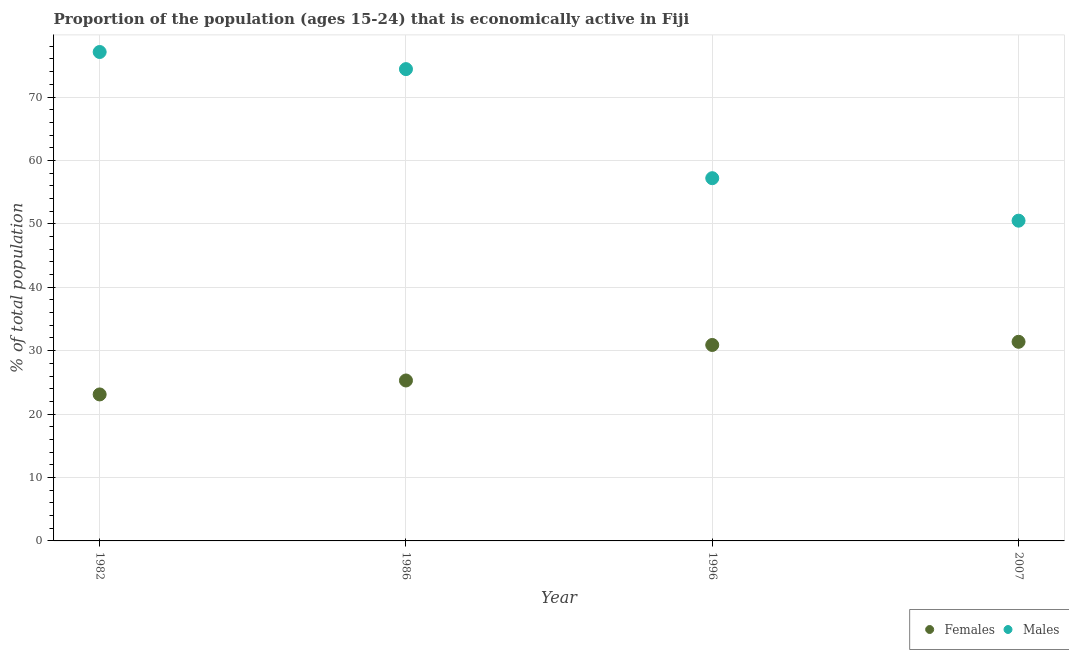Is the number of dotlines equal to the number of legend labels?
Offer a very short reply. Yes. What is the percentage of economically active male population in 1996?
Your answer should be very brief. 57.2. Across all years, what is the maximum percentage of economically active female population?
Give a very brief answer. 31.4. Across all years, what is the minimum percentage of economically active female population?
Your answer should be very brief. 23.1. In which year was the percentage of economically active male population minimum?
Your answer should be very brief. 2007. What is the total percentage of economically active male population in the graph?
Your response must be concise. 259.2. What is the difference between the percentage of economically active female population in 1986 and that in 2007?
Your answer should be compact. -6.1. What is the difference between the percentage of economically active female population in 1986 and the percentage of economically active male population in 1996?
Your answer should be compact. -31.9. What is the average percentage of economically active female population per year?
Offer a very short reply. 27.67. In the year 2007, what is the difference between the percentage of economically active male population and percentage of economically active female population?
Offer a terse response. 19.1. What is the ratio of the percentage of economically active male population in 1982 to that in 1996?
Offer a very short reply. 1.35. What is the difference between the highest and the lowest percentage of economically active female population?
Your response must be concise. 8.3. Is the sum of the percentage of economically active male population in 1982 and 1986 greater than the maximum percentage of economically active female population across all years?
Offer a terse response. Yes. Is the percentage of economically active male population strictly greater than the percentage of economically active female population over the years?
Provide a succinct answer. Yes. Is the percentage of economically active female population strictly less than the percentage of economically active male population over the years?
Offer a terse response. Yes. How many dotlines are there?
Your answer should be compact. 2. What is the difference between two consecutive major ticks on the Y-axis?
Your answer should be very brief. 10. Where does the legend appear in the graph?
Your response must be concise. Bottom right. How many legend labels are there?
Your answer should be compact. 2. What is the title of the graph?
Give a very brief answer. Proportion of the population (ages 15-24) that is economically active in Fiji. Does "Transport services" appear as one of the legend labels in the graph?
Offer a terse response. No. What is the label or title of the Y-axis?
Offer a very short reply. % of total population. What is the % of total population in Females in 1982?
Your answer should be compact. 23.1. What is the % of total population in Males in 1982?
Keep it short and to the point. 77.1. What is the % of total population in Females in 1986?
Provide a succinct answer. 25.3. What is the % of total population of Males in 1986?
Provide a succinct answer. 74.4. What is the % of total population in Females in 1996?
Your response must be concise. 30.9. What is the % of total population of Males in 1996?
Offer a very short reply. 57.2. What is the % of total population of Females in 2007?
Offer a terse response. 31.4. What is the % of total population in Males in 2007?
Give a very brief answer. 50.5. Across all years, what is the maximum % of total population in Females?
Your answer should be compact. 31.4. Across all years, what is the maximum % of total population of Males?
Offer a very short reply. 77.1. Across all years, what is the minimum % of total population in Females?
Your response must be concise. 23.1. Across all years, what is the minimum % of total population in Males?
Your answer should be compact. 50.5. What is the total % of total population of Females in the graph?
Keep it short and to the point. 110.7. What is the total % of total population of Males in the graph?
Your answer should be very brief. 259.2. What is the difference between the % of total population in Females in 1982 and that in 1986?
Give a very brief answer. -2.2. What is the difference between the % of total population of Males in 1982 and that in 1986?
Your response must be concise. 2.7. What is the difference between the % of total population of Females in 1982 and that in 1996?
Provide a succinct answer. -7.8. What is the difference between the % of total population of Males in 1982 and that in 1996?
Your response must be concise. 19.9. What is the difference between the % of total population of Males in 1982 and that in 2007?
Offer a very short reply. 26.6. What is the difference between the % of total population in Females in 1986 and that in 1996?
Keep it short and to the point. -5.6. What is the difference between the % of total population in Males in 1986 and that in 1996?
Your response must be concise. 17.2. What is the difference between the % of total population of Males in 1986 and that in 2007?
Offer a terse response. 23.9. What is the difference between the % of total population in Males in 1996 and that in 2007?
Your answer should be compact. 6.7. What is the difference between the % of total population in Females in 1982 and the % of total population in Males in 1986?
Provide a short and direct response. -51.3. What is the difference between the % of total population in Females in 1982 and the % of total population in Males in 1996?
Offer a terse response. -34.1. What is the difference between the % of total population in Females in 1982 and the % of total population in Males in 2007?
Ensure brevity in your answer.  -27.4. What is the difference between the % of total population in Females in 1986 and the % of total population in Males in 1996?
Offer a very short reply. -31.9. What is the difference between the % of total population in Females in 1986 and the % of total population in Males in 2007?
Your answer should be compact. -25.2. What is the difference between the % of total population in Females in 1996 and the % of total population in Males in 2007?
Keep it short and to the point. -19.6. What is the average % of total population of Females per year?
Your answer should be compact. 27.68. What is the average % of total population in Males per year?
Provide a succinct answer. 64.8. In the year 1982, what is the difference between the % of total population of Females and % of total population of Males?
Provide a short and direct response. -54. In the year 1986, what is the difference between the % of total population in Females and % of total population in Males?
Ensure brevity in your answer.  -49.1. In the year 1996, what is the difference between the % of total population of Females and % of total population of Males?
Provide a succinct answer. -26.3. In the year 2007, what is the difference between the % of total population in Females and % of total population in Males?
Offer a very short reply. -19.1. What is the ratio of the % of total population of Females in 1982 to that in 1986?
Give a very brief answer. 0.91. What is the ratio of the % of total population in Males in 1982 to that in 1986?
Offer a terse response. 1.04. What is the ratio of the % of total population of Females in 1982 to that in 1996?
Offer a very short reply. 0.75. What is the ratio of the % of total population in Males in 1982 to that in 1996?
Keep it short and to the point. 1.35. What is the ratio of the % of total population in Females in 1982 to that in 2007?
Your answer should be very brief. 0.74. What is the ratio of the % of total population of Males in 1982 to that in 2007?
Give a very brief answer. 1.53. What is the ratio of the % of total population of Females in 1986 to that in 1996?
Your answer should be very brief. 0.82. What is the ratio of the % of total population in Males in 1986 to that in 1996?
Make the answer very short. 1.3. What is the ratio of the % of total population in Females in 1986 to that in 2007?
Offer a very short reply. 0.81. What is the ratio of the % of total population in Males in 1986 to that in 2007?
Your answer should be compact. 1.47. What is the ratio of the % of total population in Females in 1996 to that in 2007?
Provide a short and direct response. 0.98. What is the ratio of the % of total population of Males in 1996 to that in 2007?
Give a very brief answer. 1.13. What is the difference between the highest and the second highest % of total population in Females?
Provide a short and direct response. 0.5. What is the difference between the highest and the second highest % of total population in Males?
Keep it short and to the point. 2.7. What is the difference between the highest and the lowest % of total population of Females?
Your response must be concise. 8.3. What is the difference between the highest and the lowest % of total population of Males?
Ensure brevity in your answer.  26.6. 